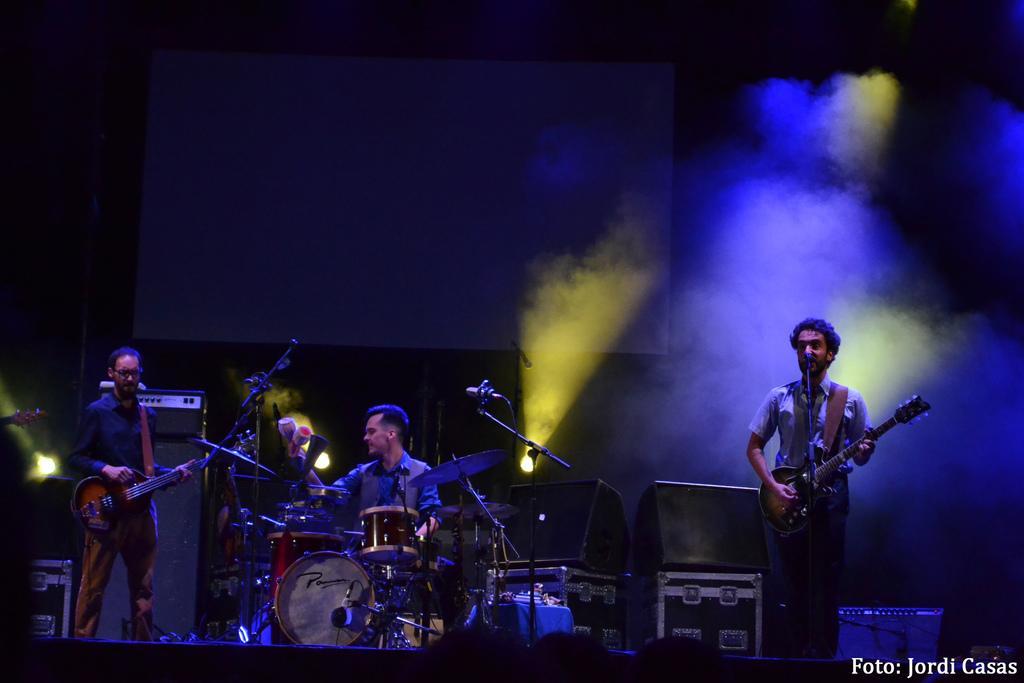Please provide a concise description of this image. There are three musicians in the picture. At the right side the man standing is holding a guitar in his hand and singing in front of the mic. At the center the man is sitting in front of the drums. At the left side the person standing is holding guitar in his hand. In the background there are speakers, fogg, white colour screen and lights. 